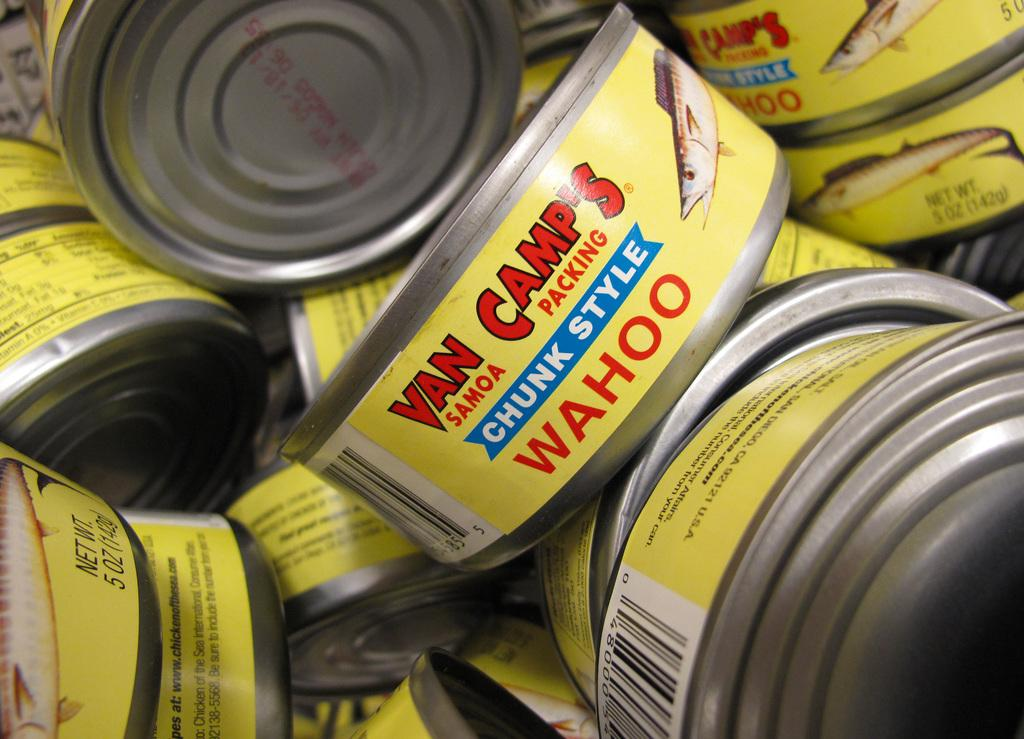<image>
Provide a brief description of the given image. Yellow cans that says Van Camps on it. 